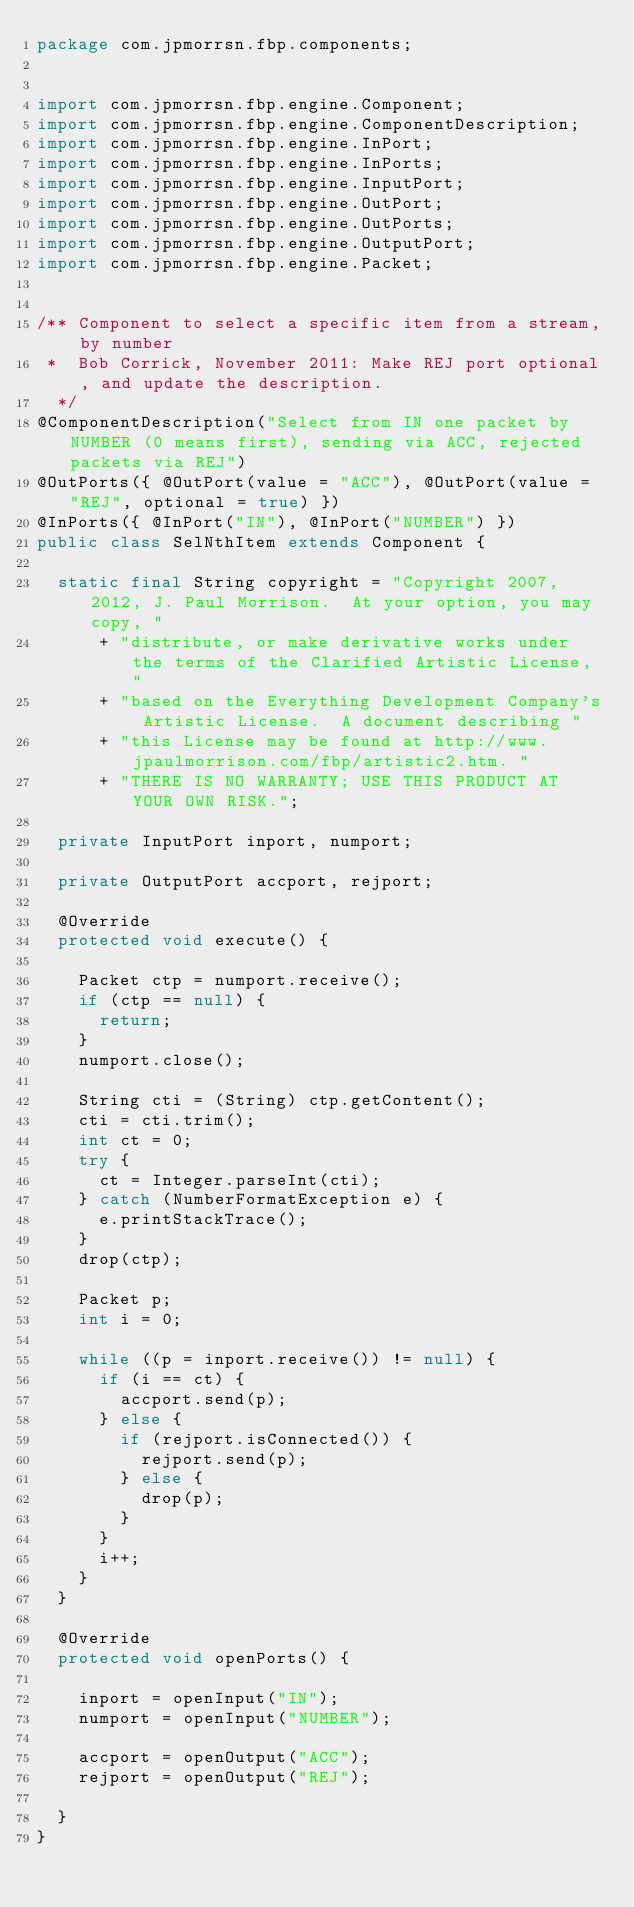Convert code to text. <code><loc_0><loc_0><loc_500><loc_500><_Java_>package com.jpmorrsn.fbp.components;


import com.jpmorrsn.fbp.engine.Component;
import com.jpmorrsn.fbp.engine.ComponentDescription;
import com.jpmorrsn.fbp.engine.InPort;
import com.jpmorrsn.fbp.engine.InPorts;
import com.jpmorrsn.fbp.engine.InputPort;
import com.jpmorrsn.fbp.engine.OutPort;
import com.jpmorrsn.fbp.engine.OutPorts;
import com.jpmorrsn.fbp.engine.OutputPort;
import com.jpmorrsn.fbp.engine.Packet;


/** Component to select a specific item from a stream, by number
 *  Bob Corrick, November 2011: Make REJ port optional, and update the description.
  */
@ComponentDescription("Select from IN one packet by NUMBER (0 means first), sending via ACC, rejected packets via REJ")
@OutPorts({ @OutPort(value = "ACC"), @OutPort(value = "REJ", optional = true) })
@InPorts({ @InPort("IN"), @InPort("NUMBER") })
public class SelNthItem extends Component {

  static final String copyright = "Copyright 2007, 2012, J. Paul Morrison.  At your option, you may copy, "
      + "distribute, or make derivative works under the terms of the Clarified Artistic License, "
      + "based on the Everything Development Company's Artistic License.  A document describing "
      + "this License may be found at http://www.jpaulmorrison.com/fbp/artistic2.htm. "
      + "THERE IS NO WARRANTY; USE THIS PRODUCT AT YOUR OWN RISK.";

  private InputPort inport, numport;

  private OutputPort accport, rejport;

  @Override
  protected void execute() {

    Packet ctp = numport.receive();
    if (ctp == null) {
      return;
    }
    numport.close();

    String cti = (String) ctp.getContent();
    cti = cti.trim();
    int ct = 0;
    try {
      ct = Integer.parseInt(cti);
    } catch (NumberFormatException e) {
      e.printStackTrace();
    }
    drop(ctp);

    Packet p;
    int i = 0;

    while ((p = inport.receive()) != null) {
      if (i == ct) {
        accport.send(p);
      } else {
        if (rejport.isConnected()) {
          rejport.send(p);
        } else {
          drop(p);
        }
      }
      i++;
    }
  }

  @Override
  protected void openPorts() {

    inport = openInput("IN");
    numport = openInput("NUMBER");

    accport = openOutput("ACC");
    rejport = openOutput("REJ");

  }
}
</code> 